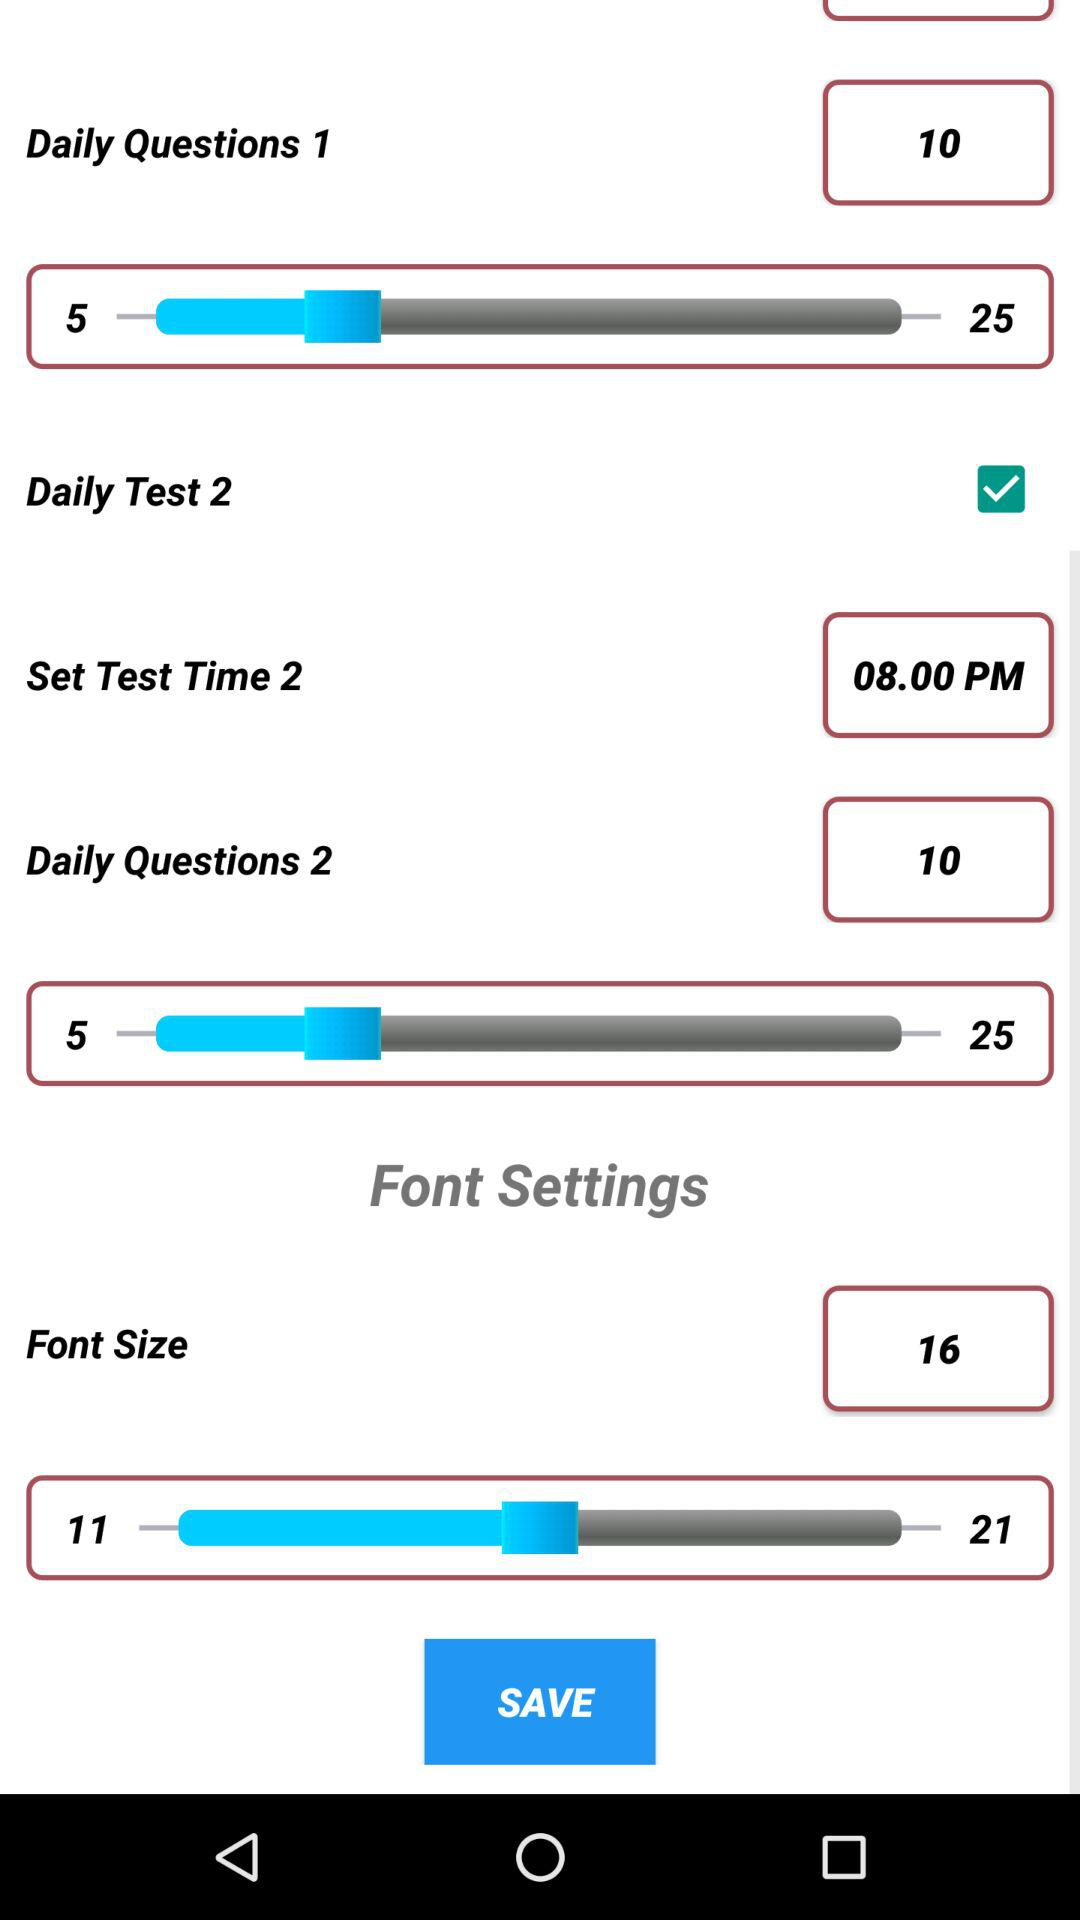What is the set font size? The set font size is 16. 